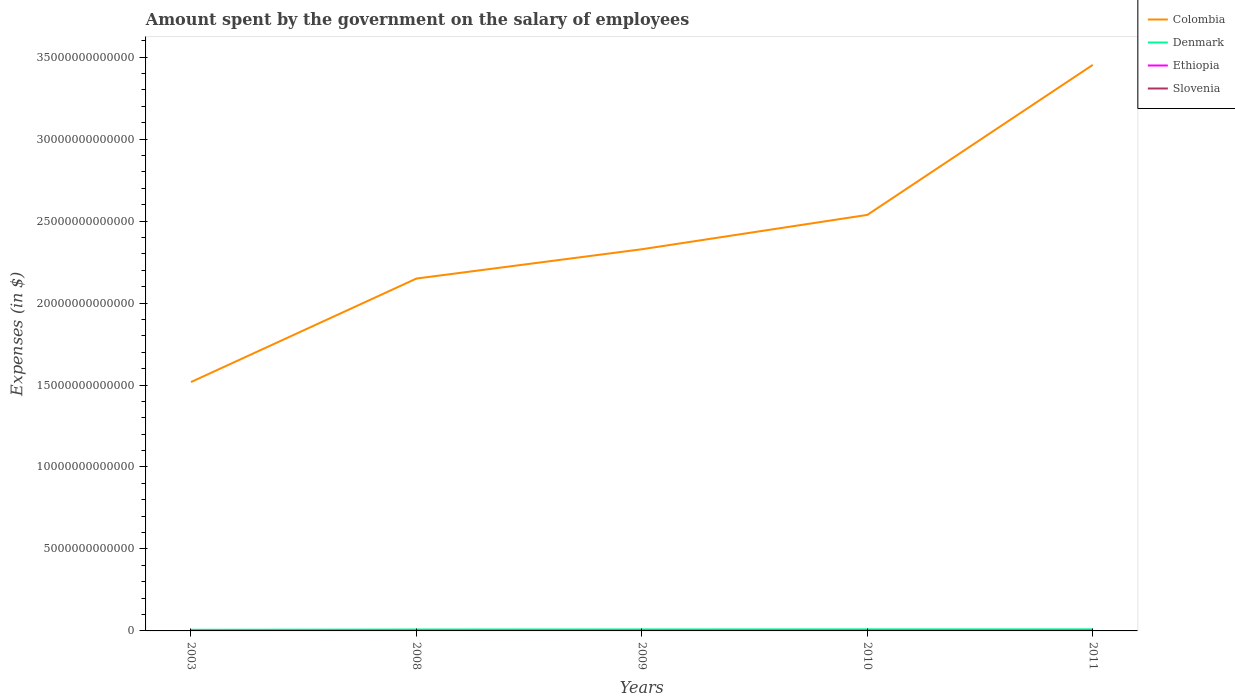Does the line corresponding to Ethiopia intersect with the line corresponding to Denmark?
Give a very brief answer. No. Across all years, what is the maximum amount spent on the salary of employees by the government in Denmark?
Make the answer very short. 6.79e+1. In which year was the amount spent on the salary of employees by the government in Ethiopia maximum?
Give a very brief answer. 2003. What is the total amount spent on the salary of employees by the government in Ethiopia in the graph?
Make the answer very short. -1.04e+09. What is the difference between the highest and the second highest amount spent on the salary of employees by the government in Colombia?
Provide a succinct answer. 1.93e+13. What is the difference between the highest and the lowest amount spent on the salary of employees by the government in Slovenia?
Your answer should be very brief. 4. Is the amount spent on the salary of employees by the government in Colombia strictly greater than the amount spent on the salary of employees by the government in Ethiopia over the years?
Ensure brevity in your answer.  No. How many years are there in the graph?
Ensure brevity in your answer.  5. What is the difference between two consecutive major ticks on the Y-axis?
Make the answer very short. 5.00e+12. Are the values on the major ticks of Y-axis written in scientific E-notation?
Offer a very short reply. No. Does the graph contain grids?
Ensure brevity in your answer.  No. Where does the legend appear in the graph?
Keep it short and to the point. Top right. How many legend labels are there?
Your response must be concise. 4. What is the title of the graph?
Your answer should be very brief. Amount spent by the government on the salary of employees. Does "El Salvador" appear as one of the legend labels in the graph?
Your response must be concise. No. What is the label or title of the Y-axis?
Ensure brevity in your answer.  Expenses (in $). What is the Expenses (in $) in Colombia in 2003?
Give a very brief answer. 1.52e+13. What is the Expenses (in $) of Denmark in 2003?
Ensure brevity in your answer.  6.79e+1. What is the Expenses (in $) of Ethiopia in 2003?
Make the answer very short. 1.98e+09. What is the Expenses (in $) of Slovenia in 2003?
Your answer should be compact. 1.87e+09. What is the Expenses (in $) in Colombia in 2008?
Make the answer very short. 2.15e+13. What is the Expenses (in $) of Denmark in 2008?
Give a very brief answer. 8.58e+1. What is the Expenses (in $) in Ethiopia in 2008?
Offer a terse response. 5.11e+09. What is the Expenses (in $) of Slovenia in 2008?
Your response must be concise. 2.67e+09. What is the Expenses (in $) in Colombia in 2009?
Ensure brevity in your answer.  2.33e+13. What is the Expenses (in $) in Denmark in 2009?
Keep it short and to the point. 9.11e+1. What is the Expenses (in $) of Ethiopia in 2009?
Make the answer very short. 6.15e+09. What is the Expenses (in $) of Slovenia in 2009?
Ensure brevity in your answer.  2.91e+09. What is the Expenses (in $) in Colombia in 2010?
Your response must be concise. 2.54e+13. What is the Expenses (in $) in Denmark in 2010?
Provide a succinct answer. 9.51e+1. What is the Expenses (in $) of Ethiopia in 2010?
Your response must be concise. 6.98e+09. What is the Expenses (in $) in Slovenia in 2010?
Give a very brief answer. 2.95e+09. What is the Expenses (in $) of Colombia in 2011?
Make the answer very short. 3.45e+13. What is the Expenses (in $) in Denmark in 2011?
Your answer should be very brief. 9.62e+1. What is the Expenses (in $) in Ethiopia in 2011?
Offer a terse response. 6.98e+09. What is the Expenses (in $) of Slovenia in 2011?
Your response must be concise. 2.94e+09. Across all years, what is the maximum Expenses (in $) in Colombia?
Ensure brevity in your answer.  3.45e+13. Across all years, what is the maximum Expenses (in $) of Denmark?
Offer a terse response. 9.62e+1. Across all years, what is the maximum Expenses (in $) in Ethiopia?
Give a very brief answer. 6.98e+09. Across all years, what is the maximum Expenses (in $) of Slovenia?
Keep it short and to the point. 2.95e+09. Across all years, what is the minimum Expenses (in $) of Colombia?
Offer a very short reply. 1.52e+13. Across all years, what is the minimum Expenses (in $) in Denmark?
Give a very brief answer. 6.79e+1. Across all years, what is the minimum Expenses (in $) in Ethiopia?
Provide a short and direct response. 1.98e+09. Across all years, what is the minimum Expenses (in $) in Slovenia?
Your answer should be compact. 1.87e+09. What is the total Expenses (in $) in Colombia in the graph?
Your response must be concise. 1.20e+14. What is the total Expenses (in $) in Denmark in the graph?
Your response must be concise. 4.36e+11. What is the total Expenses (in $) in Ethiopia in the graph?
Provide a succinct answer. 2.72e+1. What is the total Expenses (in $) of Slovenia in the graph?
Offer a terse response. 1.33e+1. What is the difference between the Expenses (in $) of Colombia in 2003 and that in 2008?
Keep it short and to the point. -6.31e+12. What is the difference between the Expenses (in $) of Denmark in 2003 and that in 2008?
Your response must be concise. -1.79e+1. What is the difference between the Expenses (in $) of Ethiopia in 2003 and that in 2008?
Your response must be concise. -3.13e+09. What is the difference between the Expenses (in $) in Slovenia in 2003 and that in 2008?
Offer a terse response. -7.97e+08. What is the difference between the Expenses (in $) of Colombia in 2003 and that in 2009?
Offer a terse response. -8.10e+12. What is the difference between the Expenses (in $) of Denmark in 2003 and that in 2009?
Provide a short and direct response. -2.32e+1. What is the difference between the Expenses (in $) in Ethiopia in 2003 and that in 2009?
Your answer should be compact. -4.17e+09. What is the difference between the Expenses (in $) of Slovenia in 2003 and that in 2009?
Provide a succinct answer. -1.03e+09. What is the difference between the Expenses (in $) of Colombia in 2003 and that in 2010?
Provide a succinct answer. -1.02e+13. What is the difference between the Expenses (in $) in Denmark in 2003 and that in 2010?
Provide a succinct answer. -2.72e+1. What is the difference between the Expenses (in $) of Ethiopia in 2003 and that in 2010?
Provide a short and direct response. -5.00e+09. What is the difference between the Expenses (in $) of Slovenia in 2003 and that in 2010?
Give a very brief answer. -1.07e+09. What is the difference between the Expenses (in $) in Colombia in 2003 and that in 2011?
Offer a very short reply. -1.93e+13. What is the difference between the Expenses (in $) in Denmark in 2003 and that in 2011?
Provide a short and direct response. -2.83e+1. What is the difference between the Expenses (in $) of Ethiopia in 2003 and that in 2011?
Your answer should be very brief. -5.00e+09. What is the difference between the Expenses (in $) of Slovenia in 2003 and that in 2011?
Make the answer very short. -1.07e+09. What is the difference between the Expenses (in $) in Colombia in 2008 and that in 2009?
Provide a short and direct response. -1.79e+12. What is the difference between the Expenses (in $) of Denmark in 2008 and that in 2009?
Ensure brevity in your answer.  -5.31e+09. What is the difference between the Expenses (in $) in Ethiopia in 2008 and that in 2009?
Your answer should be compact. -1.04e+09. What is the difference between the Expenses (in $) in Slovenia in 2008 and that in 2009?
Your answer should be compact. -2.36e+08. What is the difference between the Expenses (in $) of Colombia in 2008 and that in 2010?
Provide a short and direct response. -3.88e+12. What is the difference between the Expenses (in $) of Denmark in 2008 and that in 2010?
Provide a succinct answer. -9.33e+09. What is the difference between the Expenses (in $) of Ethiopia in 2008 and that in 2010?
Your answer should be very brief. -1.87e+09. What is the difference between the Expenses (in $) in Slovenia in 2008 and that in 2010?
Your answer should be compact. -2.75e+08. What is the difference between the Expenses (in $) of Colombia in 2008 and that in 2011?
Provide a succinct answer. -1.30e+13. What is the difference between the Expenses (in $) of Denmark in 2008 and that in 2011?
Make the answer very short. -1.04e+1. What is the difference between the Expenses (in $) of Ethiopia in 2008 and that in 2011?
Offer a very short reply. -1.87e+09. What is the difference between the Expenses (in $) of Slovenia in 2008 and that in 2011?
Your response must be concise. -2.73e+08. What is the difference between the Expenses (in $) of Colombia in 2009 and that in 2010?
Your answer should be very brief. -2.09e+12. What is the difference between the Expenses (in $) of Denmark in 2009 and that in 2010?
Offer a terse response. -4.02e+09. What is the difference between the Expenses (in $) in Ethiopia in 2009 and that in 2010?
Provide a short and direct response. -8.29e+08. What is the difference between the Expenses (in $) of Slovenia in 2009 and that in 2010?
Provide a succinct answer. -3.83e+07. What is the difference between the Expenses (in $) of Colombia in 2009 and that in 2011?
Provide a short and direct response. -1.12e+13. What is the difference between the Expenses (in $) in Denmark in 2009 and that in 2011?
Offer a terse response. -5.06e+09. What is the difference between the Expenses (in $) in Ethiopia in 2009 and that in 2011?
Your response must be concise. -8.29e+08. What is the difference between the Expenses (in $) in Slovenia in 2009 and that in 2011?
Your response must be concise. -3.63e+07. What is the difference between the Expenses (in $) in Colombia in 2010 and that in 2011?
Your answer should be compact. -9.15e+12. What is the difference between the Expenses (in $) in Denmark in 2010 and that in 2011?
Give a very brief answer. -1.04e+09. What is the difference between the Expenses (in $) in Ethiopia in 2010 and that in 2011?
Offer a terse response. 0. What is the difference between the Expenses (in $) of Slovenia in 2010 and that in 2011?
Your answer should be very brief. 1.92e+06. What is the difference between the Expenses (in $) in Colombia in 2003 and the Expenses (in $) in Denmark in 2008?
Your answer should be compact. 1.51e+13. What is the difference between the Expenses (in $) of Colombia in 2003 and the Expenses (in $) of Ethiopia in 2008?
Your answer should be very brief. 1.52e+13. What is the difference between the Expenses (in $) of Colombia in 2003 and the Expenses (in $) of Slovenia in 2008?
Provide a succinct answer. 1.52e+13. What is the difference between the Expenses (in $) of Denmark in 2003 and the Expenses (in $) of Ethiopia in 2008?
Offer a terse response. 6.28e+1. What is the difference between the Expenses (in $) in Denmark in 2003 and the Expenses (in $) in Slovenia in 2008?
Provide a short and direct response. 6.52e+1. What is the difference between the Expenses (in $) in Ethiopia in 2003 and the Expenses (in $) in Slovenia in 2008?
Provide a short and direct response. -6.93e+08. What is the difference between the Expenses (in $) in Colombia in 2003 and the Expenses (in $) in Denmark in 2009?
Make the answer very short. 1.51e+13. What is the difference between the Expenses (in $) of Colombia in 2003 and the Expenses (in $) of Ethiopia in 2009?
Keep it short and to the point. 1.52e+13. What is the difference between the Expenses (in $) of Colombia in 2003 and the Expenses (in $) of Slovenia in 2009?
Provide a short and direct response. 1.52e+13. What is the difference between the Expenses (in $) in Denmark in 2003 and the Expenses (in $) in Ethiopia in 2009?
Ensure brevity in your answer.  6.18e+1. What is the difference between the Expenses (in $) of Denmark in 2003 and the Expenses (in $) of Slovenia in 2009?
Ensure brevity in your answer.  6.50e+1. What is the difference between the Expenses (in $) in Ethiopia in 2003 and the Expenses (in $) in Slovenia in 2009?
Your response must be concise. -9.29e+08. What is the difference between the Expenses (in $) in Colombia in 2003 and the Expenses (in $) in Denmark in 2010?
Your response must be concise. 1.51e+13. What is the difference between the Expenses (in $) in Colombia in 2003 and the Expenses (in $) in Ethiopia in 2010?
Your answer should be compact. 1.52e+13. What is the difference between the Expenses (in $) in Colombia in 2003 and the Expenses (in $) in Slovenia in 2010?
Provide a short and direct response. 1.52e+13. What is the difference between the Expenses (in $) in Denmark in 2003 and the Expenses (in $) in Ethiopia in 2010?
Make the answer very short. 6.09e+1. What is the difference between the Expenses (in $) in Denmark in 2003 and the Expenses (in $) in Slovenia in 2010?
Offer a very short reply. 6.50e+1. What is the difference between the Expenses (in $) of Ethiopia in 2003 and the Expenses (in $) of Slovenia in 2010?
Your answer should be compact. -9.67e+08. What is the difference between the Expenses (in $) in Colombia in 2003 and the Expenses (in $) in Denmark in 2011?
Offer a very short reply. 1.51e+13. What is the difference between the Expenses (in $) of Colombia in 2003 and the Expenses (in $) of Ethiopia in 2011?
Offer a terse response. 1.52e+13. What is the difference between the Expenses (in $) in Colombia in 2003 and the Expenses (in $) in Slovenia in 2011?
Make the answer very short. 1.52e+13. What is the difference between the Expenses (in $) of Denmark in 2003 and the Expenses (in $) of Ethiopia in 2011?
Provide a succinct answer. 6.09e+1. What is the difference between the Expenses (in $) of Denmark in 2003 and the Expenses (in $) of Slovenia in 2011?
Provide a short and direct response. 6.50e+1. What is the difference between the Expenses (in $) in Ethiopia in 2003 and the Expenses (in $) in Slovenia in 2011?
Make the answer very short. -9.66e+08. What is the difference between the Expenses (in $) of Colombia in 2008 and the Expenses (in $) of Denmark in 2009?
Your answer should be very brief. 2.14e+13. What is the difference between the Expenses (in $) in Colombia in 2008 and the Expenses (in $) in Ethiopia in 2009?
Offer a very short reply. 2.15e+13. What is the difference between the Expenses (in $) in Colombia in 2008 and the Expenses (in $) in Slovenia in 2009?
Offer a terse response. 2.15e+13. What is the difference between the Expenses (in $) in Denmark in 2008 and the Expenses (in $) in Ethiopia in 2009?
Provide a short and direct response. 7.97e+1. What is the difference between the Expenses (in $) of Denmark in 2008 and the Expenses (in $) of Slovenia in 2009?
Give a very brief answer. 8.29e+1. What is the difference between the Expenses (in $) in Ethiopia in 2008 and the Expenses (in $) in Slovenia in 2009?
Give a very brief answer. 2.20e+09. What is the difference between the Expenses (in $) of Colombia in 2008 and the Expenses (in $) of Denmark in 2010?
Keep it short and to the point. 2.14e+13. What is the difference between the Expenses (in $) in Colombia in 2008 and the Expenses (in $) in Ethiopia in 2010?
Offer a terse response. 2.15e+13. What is the difference between the Expenses (in $) of Colombia in 2008 and the Expenses (in $) of Slovenia in 2010?
Offer a terse response. 2.15e+13. What is the difference between the Expenses (in $) of Denmark in 2008 and the Expenses (in $) of Ethiopia in 2010?
Offer a very short reply. 7.88e+1. What is the difference between the Expenses (in $) of Denmark in 2008 and the Expenses (in $) of Slovenia in 2010?
Make the answer very short. 8.29e+1. What is the difference between the Expenses (in $) in Ethiopia in 2008 and the Expenses (in $) in Slovenia in 2010?
Make the answer very short. 2.16e+09. What is the difference between the Expenses (in $) in Colombia in 2008 and the Expenses (in $) in Denmark in 2011?
Ensure brevity in your answer.  2.14e+13. What is the difference between the Expenses (in $) in Colombia in 2008 and the Expenses (in $) in Ethiopia in 2011?
Your response must be concise. 2.15e+13. What is the difference between the Expenses (in $) in Colombia in 2008 and the Expenses (in $) in Slovenia in 2011?
Provide a succinct answer. 2.15e+13. What is the difference between the Expenses (in $) of Denmark in 2008 and the Expenses (in $) of Ethiopia in 2011?
Give a very brief answer. 7.88e+1. What is the difference between the Expenses (in $) in Denmark in 2008 and the Expenses (in $) in Slovenia in 2011?
Ensure brevity in your answer.  8.29e+1. What is the difference between the Expenses (in $) of Ethiopia in 2008 and the Expenses (in $) of Slovenia in 2011?
Your response must be concise. 2.16e+09. What is the difference between the Expenses (in $) in Colombia in 2009 and the Expenses (in $) in Denmark in 2010?
Give a very brief answer. 2.32e+13. What is the difference between the Expenses (in $) in Colombia in 2009 and the Expenses (in $) in Ethiopia in 2010?
Offer a very short reply. 2.33e+13. What is the difference between the Expenses (in $) in Colombia in 2009 and the Expenses (in $) in Slovenia in 2010?
Your answer should be compact. 2.33e+13. What is the difference between the Expenses (in $) in Denmark in 2009 and the Expenses (in $) in Ethiopia in 2010?
Your answer should be very brief. 8.41e+1. What is the difference between the Expenses (in $) in Denmark in 2009 and the Expenses (in $) in Slovenia in 2010?
Ensure brevity in your answer.  8.82e+1. What is the difference between the Expenses (in $) of Ethiopia in 2009 and the Expenses (in $) of Slovenia in 2010?
Offer a terse response. 3.20e+09. What is the difference between the Expenses (in $) of Colombia in 2009 and the Expenses (in $) of Denmark in 2011?
Ensure brevity in your answer.  2.32e+13. What is the difference between the Expenses (in $) in Colombia in 2009 and the Expenses (in $) in Ethiopia in 2011?
Give a very brief answer. 2.33e+13. What is the difference between the Expenses (in $) of Colombia in 2009 and the Expenses (in $) of Slovenia in 2011?
Offer a very short reply. 2.33e+13. What is the difference between the Expenses (in $) in Denmark in 2009 and the Expenses (in $) in Ethiopia in 2011?
Make the answer very short. 8.41e+1. What is the difference between the Expenses (in $) in Denmark in 2009 and the Expenses (in $) in Slovenia in 2011?
Make the answer very short. 8.82e+1. What is the difference between the Expenses (in $) of Ethiopia in 2009 and the Expenses (in $) of Slovenia in 2011?
Provide a succinct answer. 3.21e+09. What is the difference between the Expenses (in $) of Colombia in 2010 and the Expenses (in $) of Denmark in 2011?
Offer a very short reply. 2.53e+13. What is the difference between the Expenses (in $) of Colombia in 2010 and the Expenses (in $) of Ethiopia in 2011?
Your answer should be very brief. 2.54e+13. What is the difference between the Expenses (in $) of Colombia in 2010 and the Expenses (in $) of Slovenia in 2011?
Keep it short and to the point. 2.54e+13. What is the difference between the Expenses (in $) of Denmark in 2010 and the Expenses (in $) of Ethiopia in 2011?
Your answer should be compact. 8.82e+1. What is the difference between the Expenses (in $) in Denmark in 2010 and the Expenses (in $) in Slovenia in 2011?
Give a very brief answer. 9.22e+1. What is the difference between the Expenses (in $) in Ethiopia in 2010 and the Expenses (in $) in Slovenia in 2011?
Your answer should be very brief. 4.03e+09. What is the average Expenses (in $) of Colombia per year?
Offer a terse response. 2.40e+13. What is the average Expenses (in $) of Denmark per year?
Ensure brevity in your answer.  8.72e+1. What is the average Expenses (in $) of Ethiopia per year?
Your answer should be very brief. 5.44e+09. What is the average Expenses (in $) in Slovenia per year?
Make the answer very short. 2.67e+09. In the year 2003, what is the difference between the Expenses (in $) of Colombia and Expenses (in $) of Denmark?
Your answer should be compact. 1.51e+13. In the year 2003, what is the difference between the Expenses (in $) of Colombia and Expenses (in $) of Ethiopia?
Your answer should be very brief. 1.52e+13. In the year 2003, what is the difference between the Expenses (in $) of Colombia and Expenses (in $) of Slovenia?
Offer a very short reply. 1.52e+13. In the year 2003, what is the difference between the Expenses (in $) in Denmark and Expenses (in $) in Ethiopia?
Ensure brevity in your answer.  6.59e+1. In the year 2003, what is the difference between the Expenses (in $) of Denmark and Expenses (in $) of Slovenia?
Keep it short and to the point. 6.60e+1. In the year 2003, what is the difference between the Expenses (in $) in Ethiopia and Expenses (in $) in Slovenia?
Provide a succinct answer. 1.04e+08. In the year 2008, what is the difference between the Expenses (in $) in Colombia and Expenses (in $) in Denmark?
Make the answer very short. 2.14e+13. In the year 2008, what is the difference between the Expenses (in $) in Colombia and Expenses (in $) in Ethiopia?
Provide a short and direct response. 2.15e+13. In the year 2008, what is the difference between the Expenses (in $) in Colombia and Expenses (in $) in Slovenia?
Give a very brief answer. 2.15e+13. In the year 2008, what is the difference between the Expenses (in $) of Denmark and Expenses (in $) of Ethiopia?
Provide a short and direct response. 8.07e+1. In the year 2008, what is the difference between the Expenses (in $) of Denmark and Expenses (in $) of Slovenia?
Offer a very short reply. 8.31e+1. In the year 2008, what is the difference between the Expenses (in $) in Ethiopia and Expenses (in $) in Slovenia?
Your answer should be compact. 2.44e+09. In the year 2009, what is the difference between the Expenses (in $) in Colombia and Expenses (in $) in Denmark?
Ensure brevity in your answer.  2.32e+13. In the year 2009, what is the difference between the Expenses (in $) in Colombia and Expenses (in $) in Ethiopia?
Your response must be concise. 2.33e+13. In the year 2009, what is the difference between the Expenses (in $) of Colombia and Expenses (in $) of Slovenia?
Your response must be concise. 2.33e+13. In the year 2009, what is the difference between the Expenses (in $) in Denmark and Expenses (in $) in Ethiopia?
Your answer should be very brief. 8.50e+1. In the year 2009, what is the difference between the Expenses (in $) in Denmark and Expenses (in $) in Slovenia?
Ensure brevity in your answer.  8.82e+1. In the year 2009, what is the difference between the Expenses (in $) of Ethiopia and Expenses (in $) of Slovenia?
Give a very brief answer. 3.24e+09. In the year 2010, what is the difference between the Expenses (in $) of Colombia and Expenses (in $) of Denmark?
Ensure brevity in your answer.  2.53e+13. In the year 2010, what is the difference between the Expenses (in $) of Colombia and Expenses (in $) of Ethiopia?
Provide a short and direct response. 2.54e+13. In the year 2010, what is the difference between the Expenses (in $) of Colombia and Expenses (in $) of Slovenia?
Keep it short and to the point. 2.54e+13. In the year 2010, what is the difference between the Expenses (in $) in Denmark and Expenses (in $) in Ethiopia?
Provide a short and direct response. 8.82e+1. In the year 2010, what is the difference between the Expenses (in $) in Denmark and Expenses (in $) in Slovenia?
Your answer should be compact. 9.22e+1. In the year 2010, what is the difference between the Expenses (in $) in Ethiopia and Expenses (in $) in Slovenia?
Give a very brief answer. 4.03e+09. In the year 2011, what is the difference between the Expenses (in $) in Colombia and Expenses (in $) in Denmark?
Provide a succinct answer. 3.44e+13. In the year 2011, what is the difference between the Expenses (in $) of Colombia and Expenses (in $) of Ethiopia?
Offer a very short reply. 3.45e+13. In the year 2011, what is the difference between the Expenses (in $) in Colombia and Expenses (in $) in Slovenia?
Give a very brief answer. 3.45e+13. In the year 2011, what is the difference between the Expenses (in $) of Denmark and Expenses (in $) of Ethiopia?
Offer a terse response. 8.92e+1. In the year 2011, what is the difference between the Expenses (in $) of Denmark and Expenses (in $) of Slovenia?
Give a very brief answer. 9.32e+1. In the year 2011, what is the difference between the Expenses (in $) in Ethiopia and Expenses (in $) in Slovenia?
Offer a terse response. 4.03e+09. What is the ratio of the Expenses (in $) in Colombia in 2003 to that in 2008?
Keep it short and to the point. 0.71. What is the ratio of the Expenses (in $) of Denmark in 2003 to that in 2008?
Your answer should be very brief. 0.79. What is the ratio of the Expenses (in $) of Ethiopia in 2003 to that in 2008?
Your answer should be very brief. 0.39. What is the ratio of the Expenses (in $) of Slovenia in 2003 to that in 2008?
Provide a short and direct response. 0.7. What is the ratio of the Expenses (in $) in Colombia in 2003 to that in 2009?
Your response must be concise. 0.65. What is the ratio of the Expenses (in $) in Denmark in 2003 to that in 2009?
Offer a very short reply. 0.75. What is the ratio of the Expenses (in $) of Ethiopia in 2003 to that in 2009?
Provide a short and direct response. 0.32. What is the ratio of the Expenses (in $) of Slovenia in 2003 to that in 2009?
Give a very brief answer. 0.64. What is the ratio of the Expenses (in $) of Colombia in 2003 to that in 2010?
Your answer should be very brief. 0.6. What is the ratio of the Expenses (in $) in Denmark in 2003 to that in 2010?
Provide a succinct answer. 0.71. What is the ratio of the Expenses (in $) in Ethiopia in 2003 to that in 2010?
Give a very brief answer. 0.28. What is the ratio of the Expenses (in $) in Slovenia in 2003 to that in 2010?
Give a very brief answer. 0.64. What is the ratio of the Expenses (in $) of Colombia in 2003 to that in 2011?
Provide a succinct answer. 0.44. What is the ratio of the Expenses (in $) of Denmark in 2003 to that in 2011?
Offer a very short reply. 0.71. What is the ratio of the Expenses (in $) of Ethiopia in 2003 to that in 2011?
Provide a short and direct response. 0.28. What is the ratio of the Expenses (in $) in Slovenia in 2003 to that in 2011?
Provide a succinct answer. 0.64. What is the ratio of the Expenses (in $) in Colombia in 2008 to that in 2009?
Provide a short and direct response. 0.92. What is the ratio of the Expenses (in $) of Denmark in 2008 to that in 2009?
Offer a very short reply. 0.94. What is the ratio of the Expenses (in $) in Ethiopia in 2008 to that in 2009?
Your answer should be compact. 0.83. What is the ratio of the Expenses (in $) in Slovenia in 2008 to that in 2009?
Provide a succinct answer. 0.92. What is the ratio of the Expenses (in $) in Colombia in 2008 to that in 2010?
Make the answer very short. 0.85. What is the ratio of the Expenses (in $) of Denmark in 2008 to that in 2010?
Offer a very short reply. 0.9. What is the ratio of the Expenses (in $) of Ethiopia in 2008 to that in 2010?
Ensure brevity in your answer.  0.73. What is the ratio of the Expenses (in $) in Slovenia in 2008 to that in 2010?
Keep it short and to the point. 0.91. What is the ratio of the Expenses (in $) of Colombia in 2008 to that in 2011?
Ensure brevity in your answer.  0.62. What is the ratio of the Expenses (in $) in Denmark in 2008 to that in 2011?
Provide a short and direct response. 0.89. What is the ratio of the Expenses (in $) in Ethiopia in 2008 to that in 2011?
Your answer should be compact. 0.73. What is the ratio of the Expenses (in $) in Slovenia in 2008 to that in 2011?
Give a very brief answer. 0.91. What is the ratio of the Expenses (in $) of Colombia in 2009 to that in 2010?
Ensure brevity in your answer.  0.92. What is the ratio of the Expenses (in $) in Denmark in 2009 to that in 2010?
Provide a succinct answer. 0.96. What is the ratio of the Expenses (in $) of Ethiopia in 2009 to that in 2010?
Offer a very short reply. 0.88. What is the ratio of the Expenses (in $) of Colombia in 2009 to that in 2011?
Keep it short and to the point. 0.67. What is the ratio of the Expenses (in $) in Denmark in 2009 to that in 2011?
Give a very brief answer. 0.95. What is the ratio of the Expenses (in $) in Ethiopia in 2009 to that in 2011?
Offer a very short reply. 0.88. What is the ratio of the Expenses (in $) of Slovenia in 2009 to that in 2011?
Provide a short and direct response. 0.99. What is the ratio of the Expenses (in $) of Colombia in 2010 to that in 2011?
Offer a very short reply. 0.73. What is the ratio of the Expenses (in $) of Denmark in 2010 to that in 2011?
Your answer should be compact. 0.99. What is the ratio of the Expenses (in $) in Slovenia in 2010 to that in 2011?
Your response must be concise. 1. What is the difference between the highest and the second highest Expenses (in $) in Colombia?
Give a very brief answer. 9.15e+12. What is the difference between the highest and the second highest Expenses (in $) of Denmark?
Offer a terse response. 1.04e+09. What is the difference between the highest and the second highest Expenses (in $) of Slovenia?
Keep it short and to the point. 1.92e+06. What is the difference between the highest and the lowest Expenses (in $) in Colombia?
Provide a short and direct response. 1.93e+13. What is the difference between the highest and the lowest Expenses (in $) in Denmark?
Provide a short and direct response. 2.83e+1. What is the difference between the highest and the lowest Expenses (in $) of Ethiopia?
Your answer should be compact. 5.00e+09. What is the difference between the highest and the lowest Expenses (in $) in Slovenia?
Your response must be concise. 1.07e+09. 